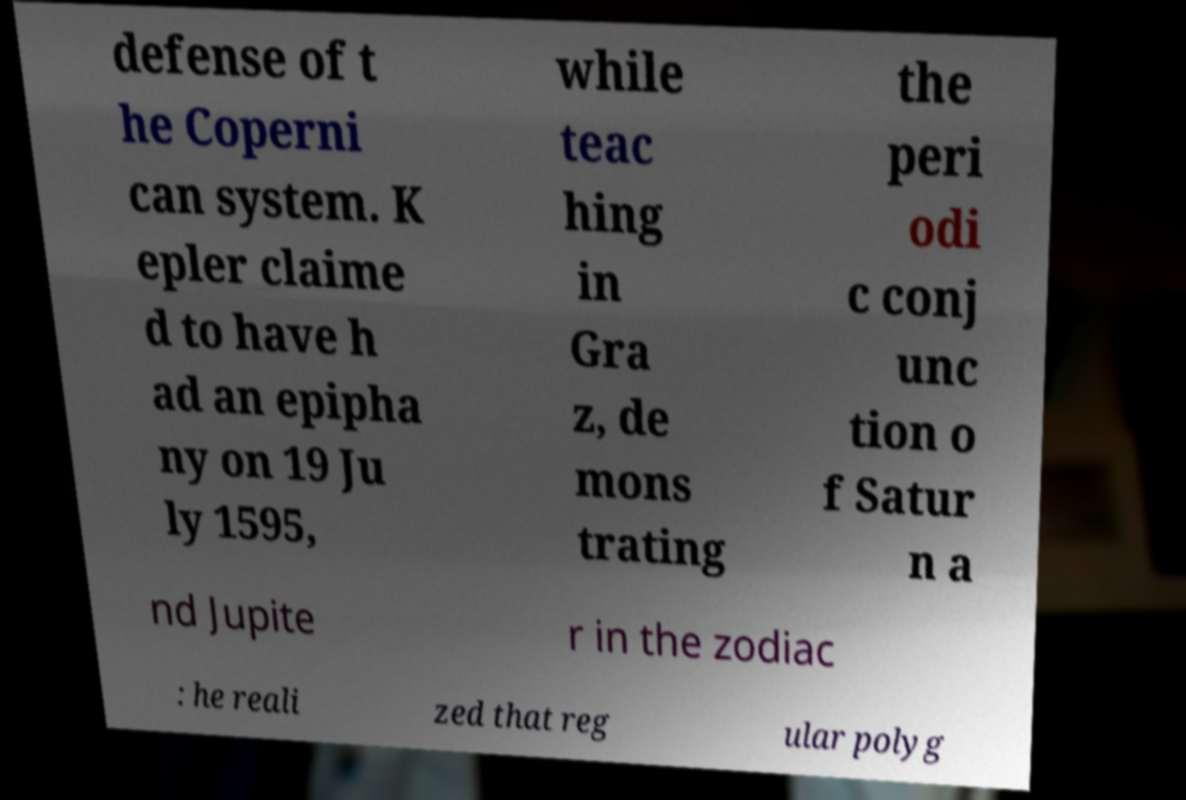There's text embedded in this image that I need extracted. Can you transcribe it verbatim? defense of t he Coperni can system. K epler claime d to have h ad an epipha ny on 19 Ju ly 1595, while teac hing in Gra z, de mons trating the peri odi c conj unc tion o f Satur n a nd Jupite r in the zodiac : he reali zed that reg ular polyg 